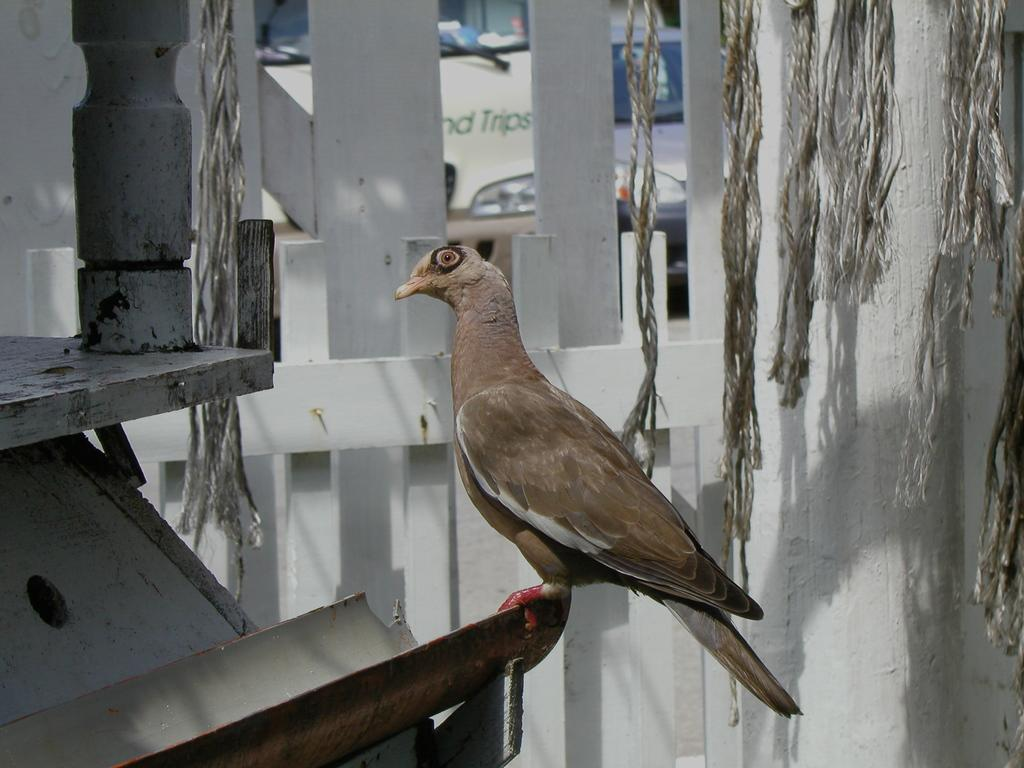What type of animal can be seen in the image? There is a bird in the image. Where is the bird located? The bird is sitting on an iron bar. What type of fencing is present in the image? There is wooden fencing in the image. What other objects can be seen in the image? There are ropes in the image. What color is the robin in the image? There is no robin present in the image; it features a bird, but the specific type of bird is not mentioned. What type of fruit is the bird holding in the image? There is no fruit, including oranges, present in the image. 